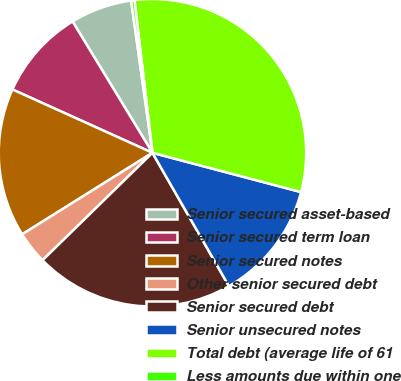Convert chart to OTSL. <chart><loc_0><loc_0><loc_500><loc_500><pie_chart><fcel>Senior secured asset-based<fcel>Senior secured term loan<fcel>Senior secured notes<fcel>Other senior secured debt<fcel>Senior secured debt<fcel>Senior unsecured notes<fcel>Total debt (average life of 61<fcel>Less amounts due within one<nl><fcel>6.48%<fcel>9.54%<fcel>15.66%<fcel>3.42%<fcel>20.97%<fcel>12.6%<fcel>30.98%<fcel>0.35%<nl></chart> 